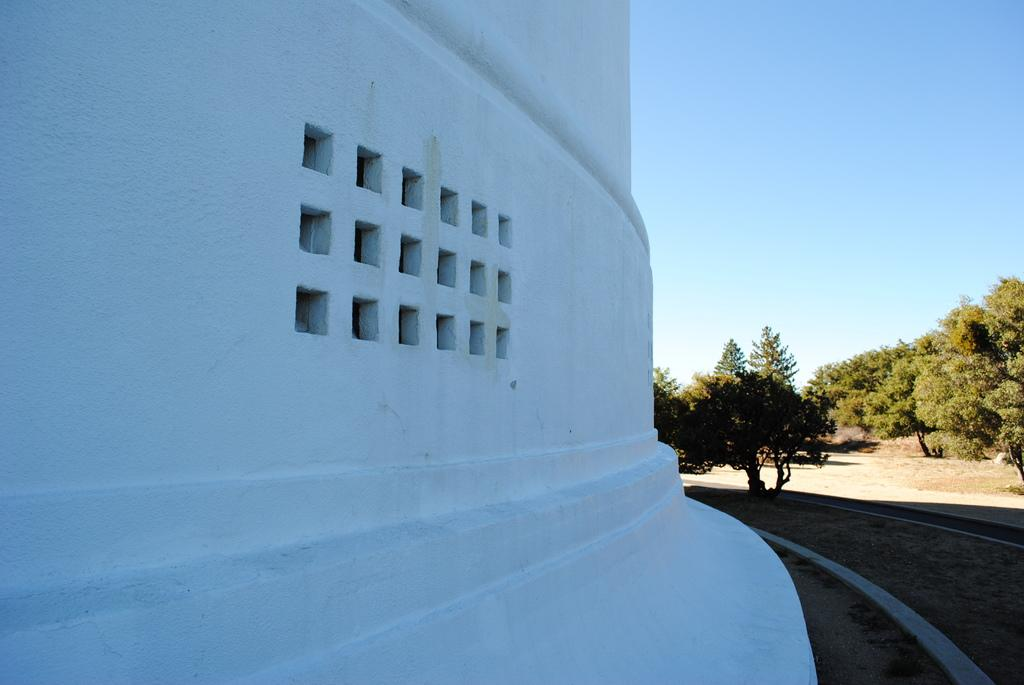What type of surface can be seen on the right side of the image? There is a walkway on the right side of the image. What is located on the right side of the walkway? There are trees on the right side of the image. What is visible on the ground in the image? The ground is visible in the image. What is visible above the ground in the image? The sky is visible in the image. What type of territory is being claimed by the trees in the image? There is no indication in the image that the trees are claiming any territory. How does the sun appear in the image? The provided facts do not mention the sun, so we cannot determine its appearance in the image. 